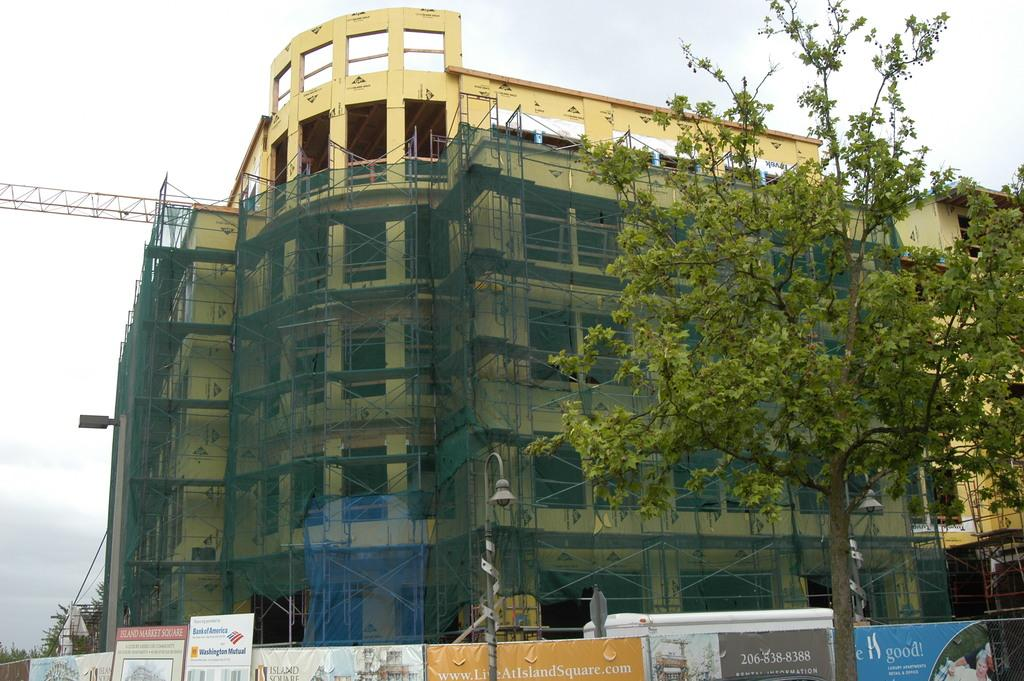What type of structure is visible in the image? There is a building in the image. What is located in front of the building? A tree is present in front of the building. What encloses the area around the building? There is a fence surrounding the building. What can be seen above the building? The sky is visible above the building. How many beads are hanging from the tree in the image? There are no beads present in the image; the tree is not described as having any beads. 